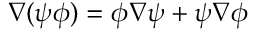Convert formula to latex. <formula><loc_0><loc_0><loc_500><loc_500>\nabla ( \psi \phi ) = \phi \nabla \psi + \psi \nabla \phi</formula> 